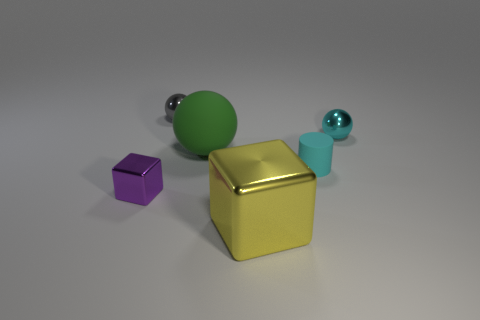Subtract all brown balls. Subtract all green blocks. How many balls are left? 3 Subtract all yellow spheres. How many brown cylinders are left? 0 Add 4 yellows. How many cyans exist? 0 Subtract all gray metal objects. Subtract all small cyan cylinders. How many objects are left? 4 Add 1 large green things. How many large green things are left? 2 Add 2 purple blocks. How many purple blocks exist? 3 Add 4 green cubes. How many objects exist? 10 Subtract all yellow cubes. How many cubes are left? 1 Subtract all metal balls. How many balls are left? 1 Subtract 0 gray cylinders. How many objects are left? 6 